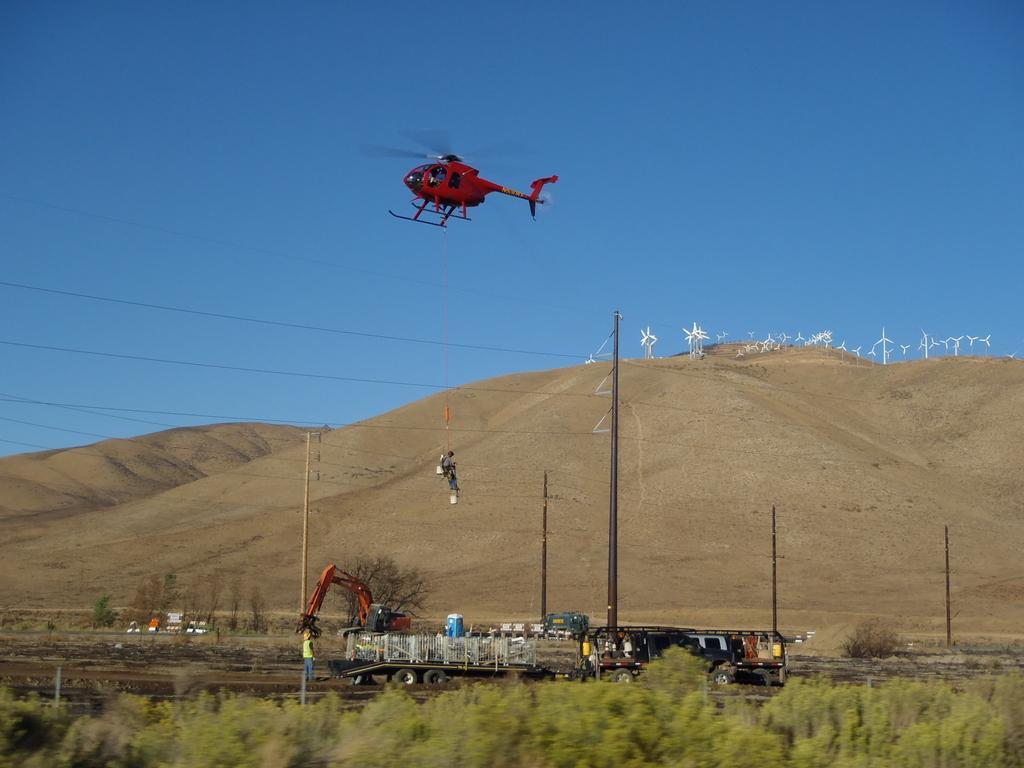Can you describe this image briefly? In this image there are some vehicles on the path, grass, plants, poles, a helicopter flying in the sky ,and a person hanging with the rope from the helicopter ,windmills on the hills, sky. 